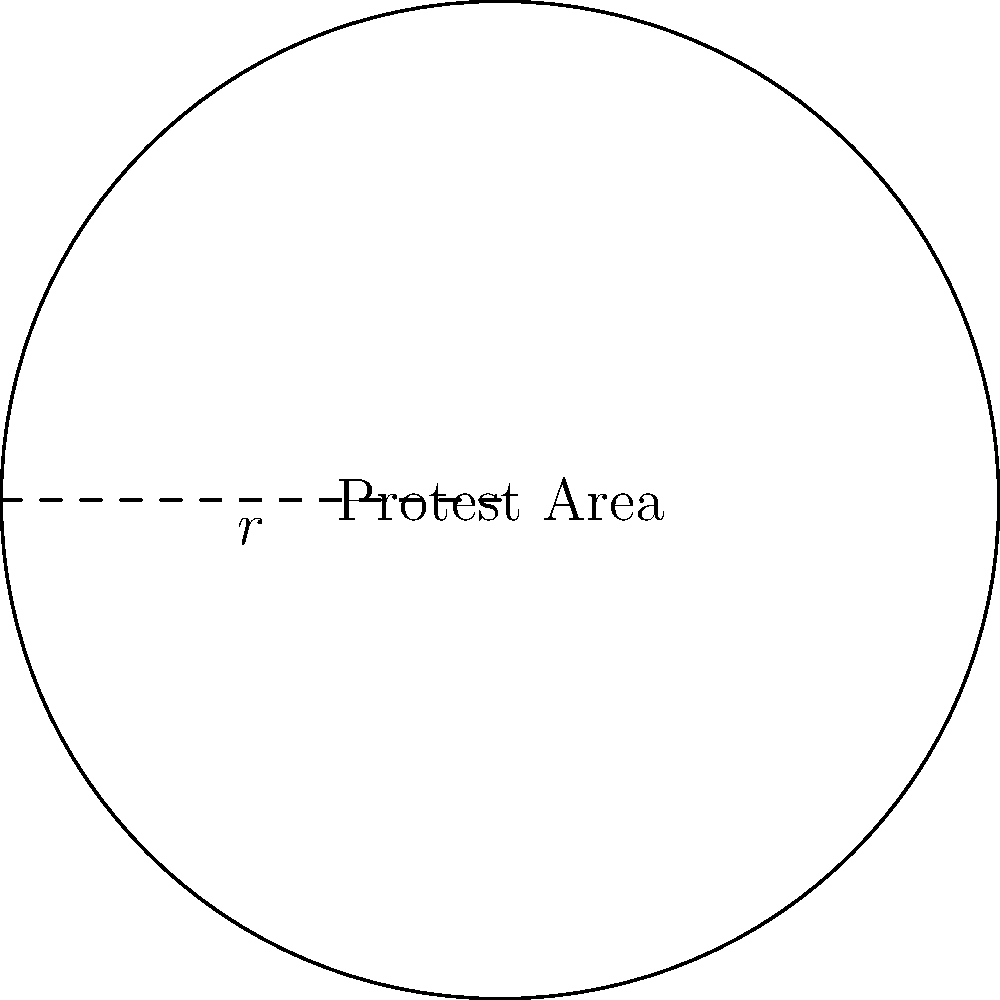In Moscow, a circular area has been designated for a peaceful protest against government censorship. If the radius of this circular protest zone is 50 meters, what is the perimeter of the area that needs to be secured by the organizers? To find the perimeter of a circular area, we need to use the formula for the circumference of a circle. Let's approach this step-by-step:

1) The formula for the circumference (perimeter) of a circle is:
   $C = 2\pi r$, where $C$ is the circumference, $\pi$ is pi, and $r$ is the radius.

2) We are given that the radius is 50 meters.

3) Let's substitute these values into our formula:
   $C = 2\pi (50)$

4) $\pi$ is approximately equal to 3.14159, so we can use this value:
   $C = 2(3.14159)(50)$

5) Let's calculate:
   $C = 314.159$ meters

6) Rounding to the nearest meter:
   $C \approx 314$ meters

Therefore, the perimeter of the circular protest area that needs to be secured is approximately 314 meters.
Answer: $314$ meters 